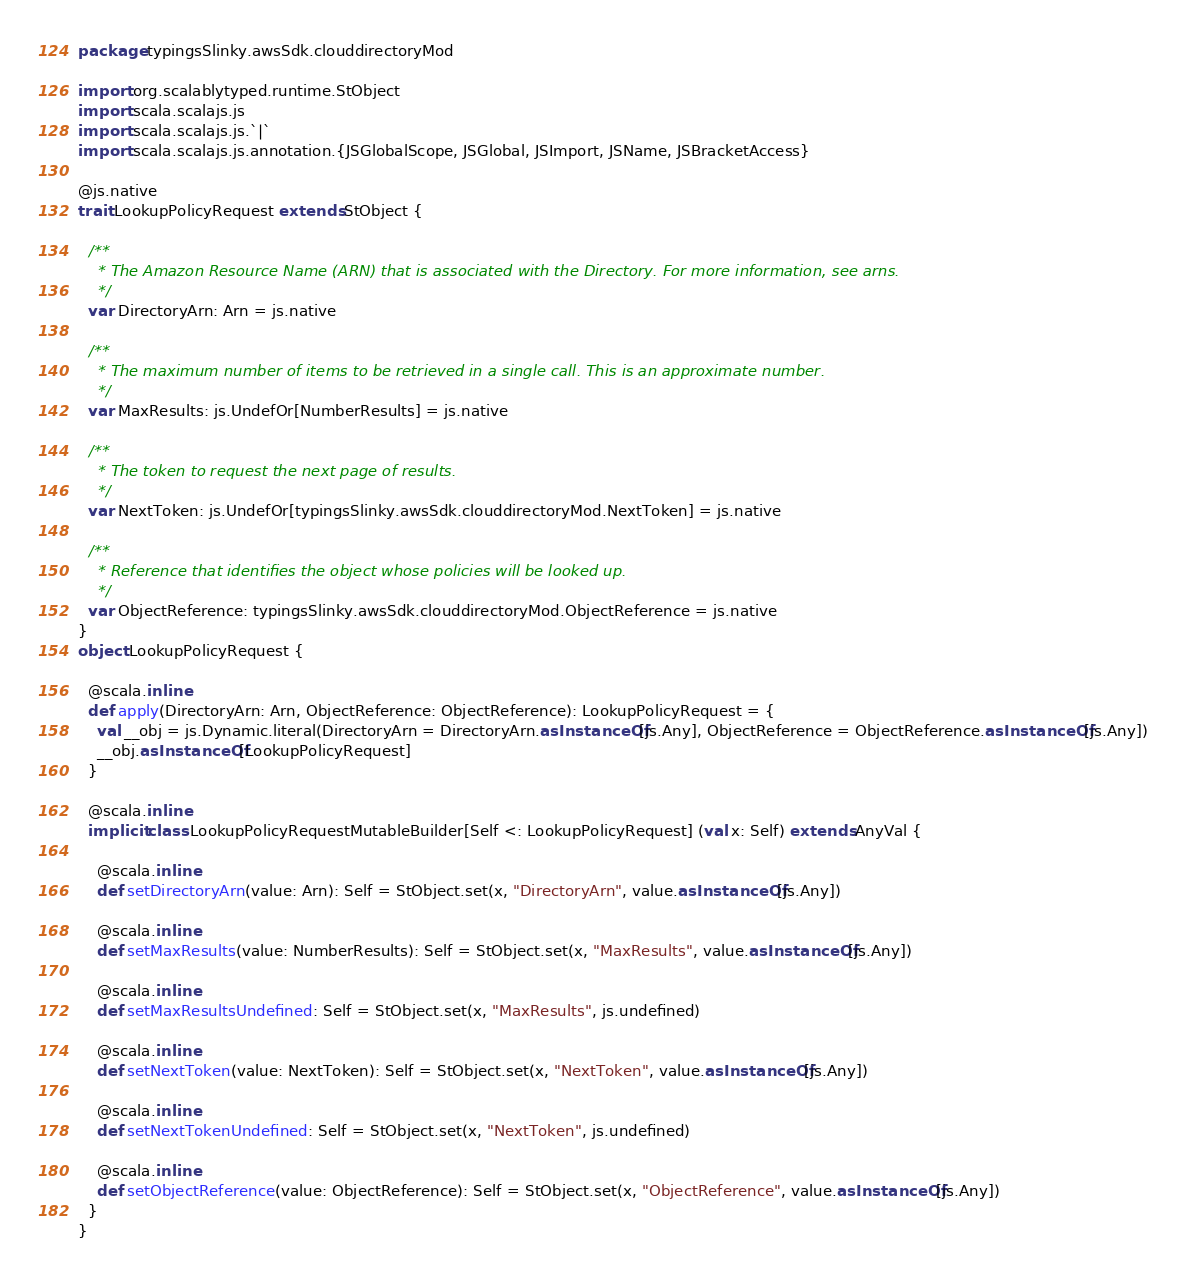Convert code to text. <code><loc_0><loc_0><loc_500><loc_500><_Scala_>package typingsSlinky.awsSdk.clouddirectoryMod

import org.scalablytyped.runtime.StObject
import scala.scalajs.js
import scala.scalajs.js.`|`
import scala.scalajs.js.annotation.{JSGlobalScope, JSGlobal, JSImport, JSName, JSBracketAccess}

@js.native
trait LookupPolicyRequest extends StObject {
  
  /**
    * The Amazon Resource Name (ARN) that is associated with the Directory. For more information, see arns.
    */
  var DirectoryArn: Arn = js.native
  
  /**
    * The maximum number of items to be retrieved in a single call. This is an approximate number.
    */
  var MaxResults: js.UndefOr[NumberResults] = js.native
  
  /**
    * The token to request the next page of results.
    */
  var NextToken: js.UndefOr[typingsSlinky.awsSdk.clouddirectoryMod.NextToken] = js.native
  
  /**
    * Reference that identifies the object whose policies will be looked up.
    */
  var ObjectReference: typingsSlinky.awsSdk.clouddirectoryMod.ObjectReference = js.native
}
object LookupPolicyRequest {
  
  @scala.inline
  def apply(DirectoryArn: Arn, ObjectReference: ObjectReference): LookupPolicyRequest = {
    val __obj = js.Dynamic.literal(DirectoryArn = DirectoryArn.asInstanceOf[js.Any], ObjectReference = ObjectReference.asInstanceOf[js.Any])
    __obj.asInstanceOf[LookupPolicyRequest]
  }
  
  @scala.inline
  implicit class LookupPolicyRequestMutableBuilder[Self <: LookupPolicyRequest] (val x: Self) extends AnyVal {
    
    @scala.inline
    def setDirectoryArn(value: Arn): Self = StObject.set(x, "DirectoryArn", value.asInstanceOf[js.Any])
    
    @scala.inline
    def setMaxResults(value: NumberResults): Self = StObject.set(x, "MaxResults", value.asInstanceOf[js.Any])
    
    @scala.inline
    def setMaxResultsUndefined: Self = StObject.set(x, "MaxResults", js.undefined)
    
    @scala.inline
    def setNextToken(value: NextToken): Self = StObject.set(x, "NextToken", value.asInstanceOf[js.Any])
    
    @scala.inline
    def setNextTokenUndefined: Self = StObject.set(x, "NextToken", js.undefined)
    
    @scala.inline
    def setObjectReference(value: ObjectReference): Self = StObject.set(x, "ObjectReference", value.asInstanceOf[js.Any])
  }
}
</code> 